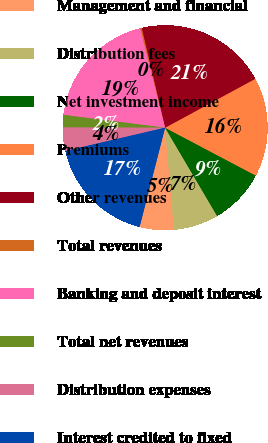Convert chart to OTSL. <chart><loc_0><loc_0><loc_500><loc_500><pie_chart><fcel>Management and financial<fcel>Distribution fees<fcel>Net investment income<fcel>Premiums<fcel>Other revenues<fcel>Total revenues<fcel>Banking and deposit interest<fcel>Total net revenues<fcel>Distribution expenses<fcel>Interest credited to fixed<nl><fcel>5.39%<fcel>7.09%<fcel>8.8%<fcel>15.64%<fcel>20.77%<fcel>0.26%<fcel>19.06%<fcel>1.97%<fcel>3.68%<fcel>17.35%<nl></chart> 